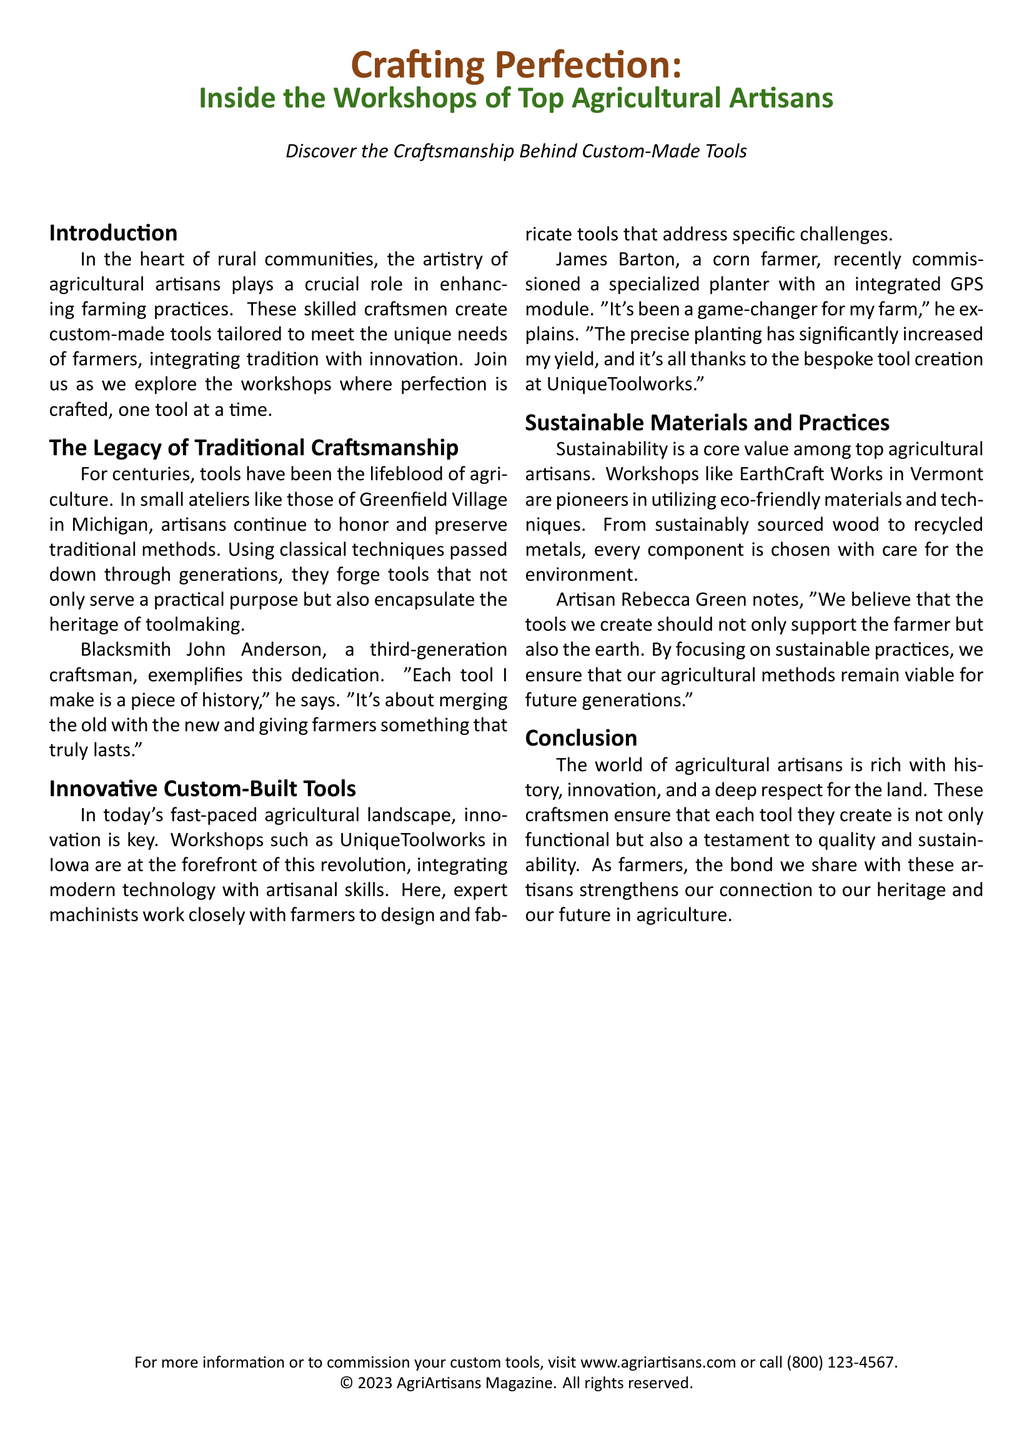What is the title of the article? The title of the article is clearly stated at the top of the document: "Crafting Perfection."
Answer: Crafting Perfection Who is the blacksmith mentioned in the document? The document mentions Blacksmith John Anderson as a third-generation craftsman.
Answer: John Anderson What is the name of the innovative workshop in Iowa? The innovative workshop in Iowa is referred to as UniqueToolworks.
Answer: UniqueToolworks Which state is EarthCraft Works located in? The document states that EarthCraft Works is located in Vermont.
Answer: Vermont What type of module did James Barton commission for his planter? The planter commissioned by James Barton included an integrated GPS module.
Answer: GPS module What is a core value among top agricultural artisans? The document emphasizes that sustainability is a core value among top agricultural artisans.
Answer: Sustainability How long has John Anderson been a craftsman? John Anderson is identified as a third-generation craftsman, which implies his family has been crafting for generations.
Answer: Generations What is the website mentioned for commissioning custom tools? The document provides the website www.agriartisans.com for further information or commissioning tools.
Answer: www.agriartisans.com 